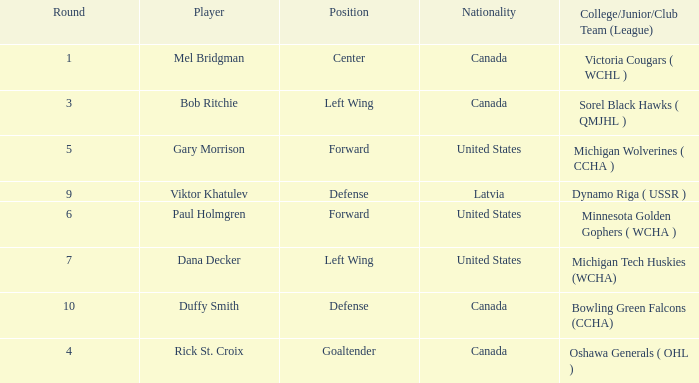I'm looking to parse the entire table for insights. Could you assist me with that? {'header': ['Round', 'Player', 'Position', 'Nationality', 'College/Junior/Club Team (League)'], 'rows': [['1', 'Mel Bridgman', 'Center', 'Canada', 'Victoria Cougars ( WCHL )'], ['3', 'Bob Ritchie', 'Left Wing', 'Canada', 'Sorel Black Hawks ( QMJHL )'], ['5', 'Gary Morrison', 'Forward', 'United States', 'Michigan Wolverines ( CCHA )'], ['9', 'Viktor Khatulev', 'Defense', 'Latvia', 'Dynamo Riga ( USSR )'], ['6', 'Paul Holmgren', 'Forward', 'United States', 'Minnesota Golden Gophers ( WCHA )'], ['7', 'Dana Decker', 'Left Wing', 'United States', 'Michigan Tech Huskies (WCHA)'], ['10', 'Duffy Smith', 'Defense', 'Canada', 'Bowling Green Falcons (CCHA)'], ['4', 'Rick St. Croix', 'Goaltender', 'Canada', 'Oshawa Generals ( OHL )']]} What College/Junior/Club Team (League) has 6 as the Round? Minnesota Golden Gophers ( WCHA ). 